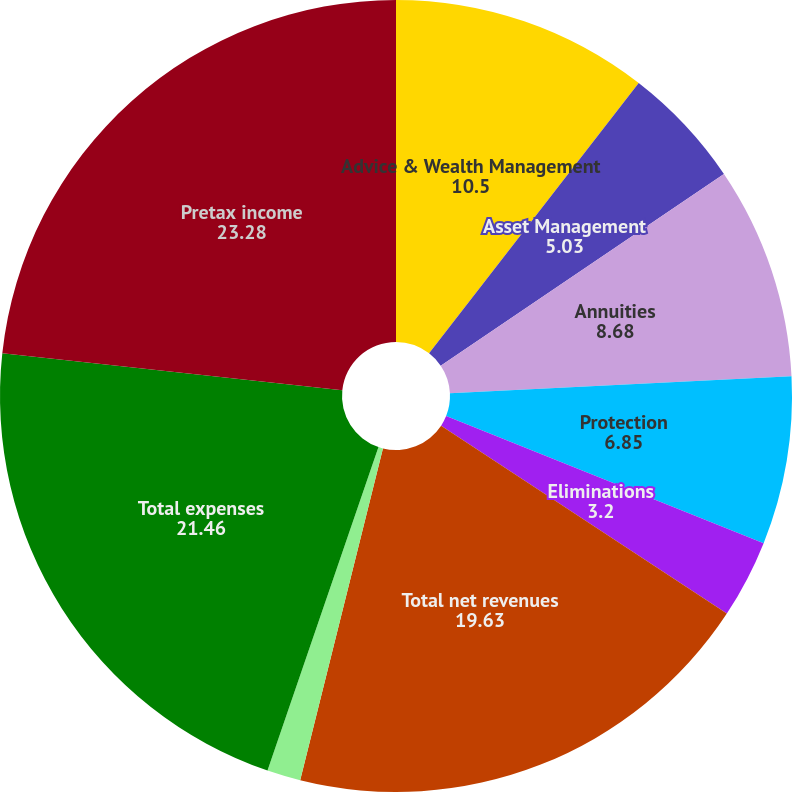<chart> <loc_0><loc_0><loc_500><loc_500><pie_chart><fcel>Advice & Wealth Management<fcel>Asset Management<fcel>Annuities<fcel>Protection<fcel>Eliminations<fcel>Total net revenues<fcel>Corporate & Other<fcel>Total expenses<fcel>Pretax income<nl><fcel>10.5%<fcel>5.03%<fcel>8.68%<fcel>6.85%<fcel>3.2%<fcel>19.63%<fcel>1.37%<fcel>21.46%<fcel>23.28%<nl></chart> 